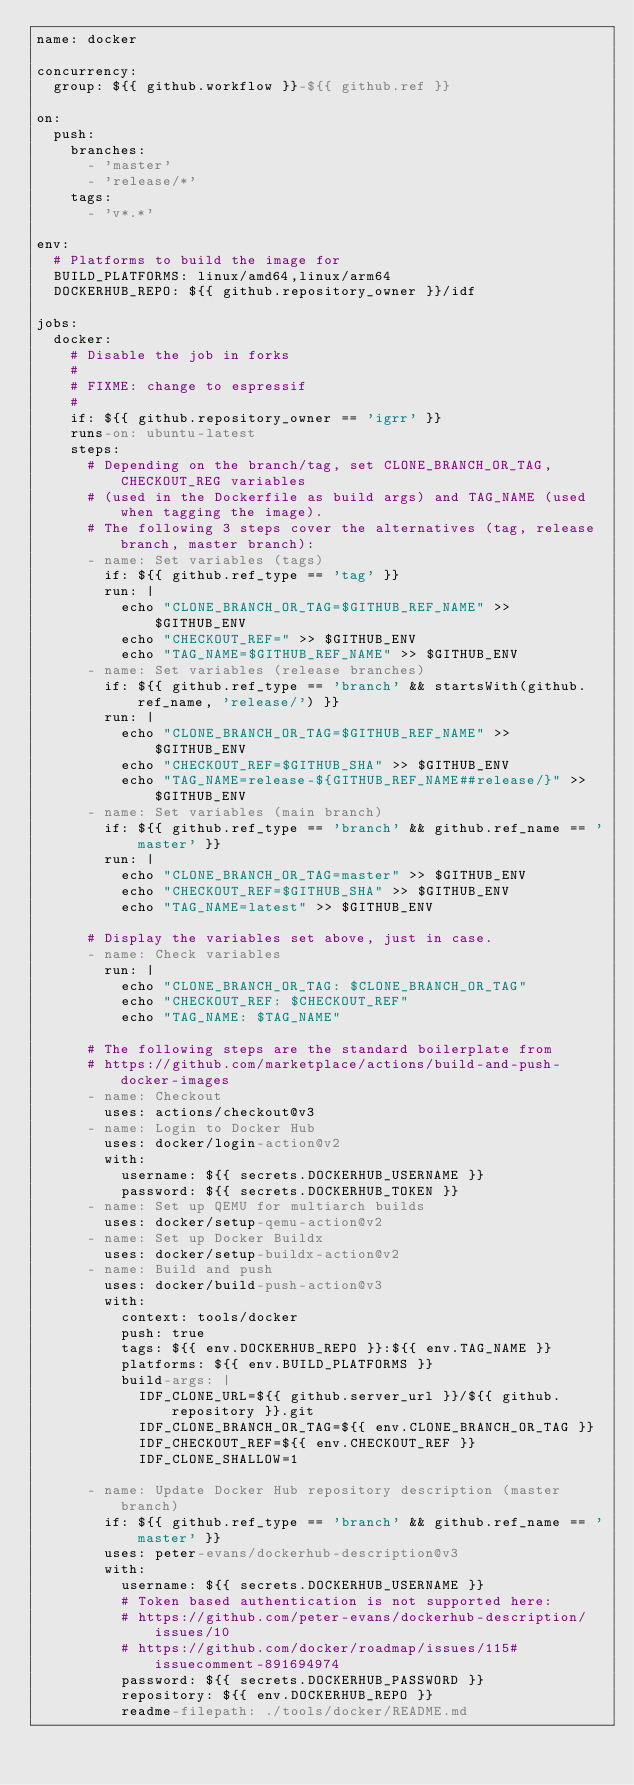Convert code to text. <code><loc_0><loc_0><loc_500><loc_500><_YAML_>name: docker

concurrency:
  group: ${{ github.workflow }}-${{ github.ref }}

on:
  push:
    branches:
      - 'master'
      - 'release/*'
    tags:
      - 'v*.*'

env:
  # Platforms to build the image for
  BUILD_PLATFORMS: linux/amd64,linux/arm64
  DOCKERHUB_REPO: ${{ github.repository_owner }}/idf

jobs:
  docker:
    # Disable the job in forks
    #
    # FIXME: change to espressif
    #
    if: ${{ github.repository_owner == 'igrr' }}
    runs-on: ubuntu-latest
    steps:
      # Depending on the branch/tag, set CLONE_BRANCH_OR_TAG, CHECKOUT_REG variables
      # (used in the Dockerfile as build args) and TAG_NAME (used when tagging the image).
      # The following 3 steps cover the alternatives (tag, release branch, master branch):
      - name: Set variables (tags)
        if: ${{ github.ref_type == 'tag' }}
        run: |
          echo "CLONE_BRANCH_OR_TAG=$GITHUB_REF_NAME" >> $GITHUB_ENV
          echo "CHECKOUT_REF=" >> $GITHUB_ENV
          echo "TAG_NAME=$GITHUB_REF_NAME" >> $GITHUB_ENV
      - name: Set variables (release branches)
        if: ${{ github.ref_type == 'branch' && startsWith(github.ref_name, 'release/') }}
        run: |
          echo "CLONE_BRANCH_OR_TAG=$GITHUB_REF_NAME" >> $GITHUB_ENV
          echo "CHECKOUT_REF=$GITHUB_SHA" >> $GITHUB_ENV
          echo "TAG_NAME=release-${GITHUB_REF_NAME##release/}" >> $GITHUB_ENV
      - name: Set variables (main branch)
        if: ${{ github.ref_type == 'branch' && github.ref_name == 'master' }}
        run: |
          echo "CLONE_BRANCH_OR_TAG=master" >> $GITHUB_ENV
          echo "CHECKOUT_REF=$GITHUB_SHA" >> $GITHUB_ENV
          echo "TAG_NAME=latest" >> $GITHUB_ENV

      # Display the variables set above, just in case.
      - name: Check variables
        run: |
          echo "CLONE_BRANCH_OR_TAG: $CLONE_BRANCH_OR_TAG"
          echo "CHECKOUT_REF: $CHECKOUT_REF"
          echo "TAG_NAME: $TAG_NAME"

      # The following steps are the standard boilerplate from
      # https://github.com/marketplace/actions/build-and-push-docker-images
      - name: Checkout
        uses: actions/checkout@v3
      - name: Login to Docker Hub
        uses: docker/login-action@v2
        with:
          username: ${{ secrets.DOCKERHUB_USERNAME }}
          password: ${{ secrets.DOCKERHUB_TOKEN }}
      - name: Set up QEMU for multiarch builds
        uses: docker/setup-qemu-action@v2
      - name: Set up Docker Buildx
        uses: docker/setup-buildx-action@v2
      - name: Build and push
        uses: docker/build-push-action@v3
        with:
          context: tools/docker
          push: true
          tags: ${{ env.DOCKERHUB_REPO }}:${{ env.TAG_NAME }}
          platforms: ${{ env.BUILD_PLATFORMS }}
          build-args: |
            IDF_CLONE_URL=${{ github.server_url }}/${{ github.repository }}.git
            IDF_CLONE_BRANCH_OR_TAG=${{ env.CLONE_BRANCH_OR_TAG }}
            IDF_CHECKOUT_REF=${{ env.CHECKOUT_REF }}
            IDF_CLONE_SHALLOW=1

      - name: Update Docker Hub repository description (master branch)
        if: ${{ github.ref_type == 'branch' && github.ref_name == 'master' }}
        uses: peter-evans/dockerhub-description@v3
        with:
          username: ${{ secrets.DOCKERHUB_USERNAME }}
          # Token based authentication is not supported here:
          # https://github.com/peter-evans/dockerhub-description/issues/10
          # https://github.com/docker/roadmap/issues/115#issuecomment-891694974
          password: ${{ secrets.DOCKERHUB_PASSWORD }}
          repository: ${{ env.DOCKERHUB_REPO }}
          readme-filepath: ./tools/docker/README.md
</code> 